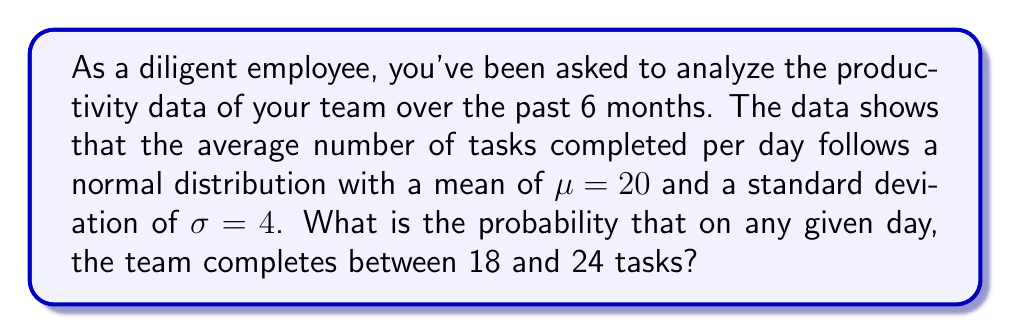Show me your answer to this math problem. To solve this problem, we'll use the standard normal distribution (z-score) and the z-table.

Step 1: Calculate the z-scores for the given values.
For 18 tasks: $z_1 = \frac{18 - \mu}{\sigma} = \frac{18 - 20}{4} = -0.5$
For 24 tasks: $z_2 = \frac{24 - \mu}{\sigma} = \frac{24 - 20}{4} = 1$

Step 2: Find the area under the standard normal curve between these z-scores.
Area = P(-0.5 < Z < 1)

Step 3: Use the z-table to find the cumulative probabilities.
P(Z < -0.5) ≈ 0.3085
P(Z < 1) ≈ 0.8413

Step 4: Calculate the difference between these probabilities.
P(-0.5 < Z < 1) = P(Z < 1) - P(Z < -0.5)
                = 0.8413 - 0.3085
                = 0.5328

Therefore, the probability that the team completes between 18 and 24 tasks on any given day is approximately 0.5328 or 53.28%.
Answer: 0.5328 